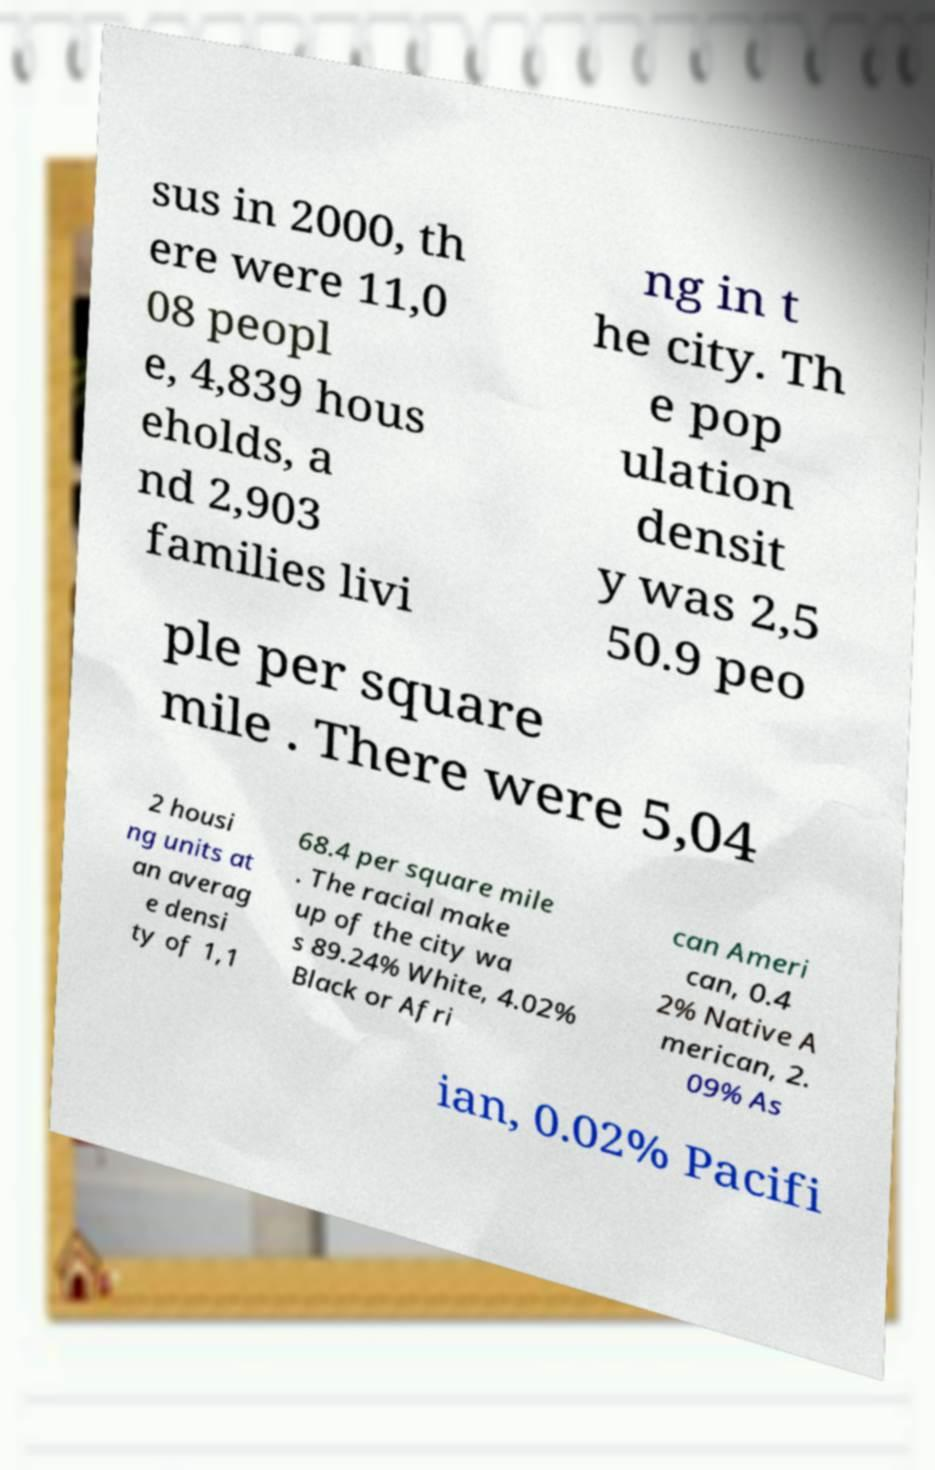I need the written content from this picture converted into text. Can you do that? sus in 2000, th ere were 11,0 08 peopl e, 4,839 hous eholds, a nd 2,903 families livi ng in t he city. Th e pop ulation densit y was 2,5 50.9 peo ple per square mile . There were 5,04 2 housi ng units at an averag e densi ty of 1,1 68.4 per square mile . The racial make up of the city wa s 89.24% White, 4.02% Black or Afri can Ameri can, 0.4 2% Native A merican, 2. 09% As ian, 0.02% Pacifi 